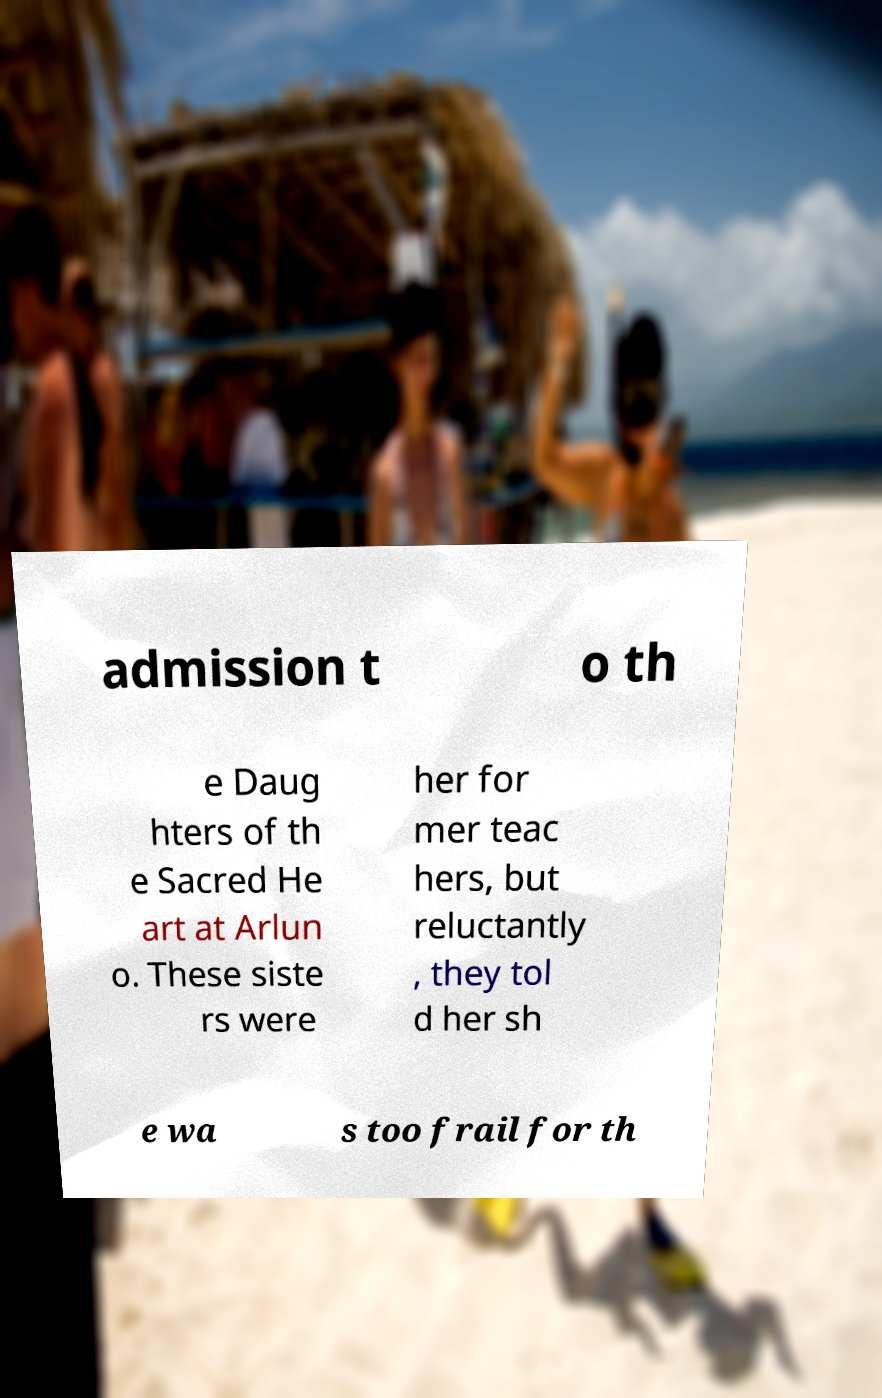Could you assist in decoding the text presented in this image and type it out clearly? admission t o th e Daug hters of th e Sacred He art at Arlun o. These siste rs were her for mer teac hers, but reluctantly , they tol d her sh e wa s too frail for th 